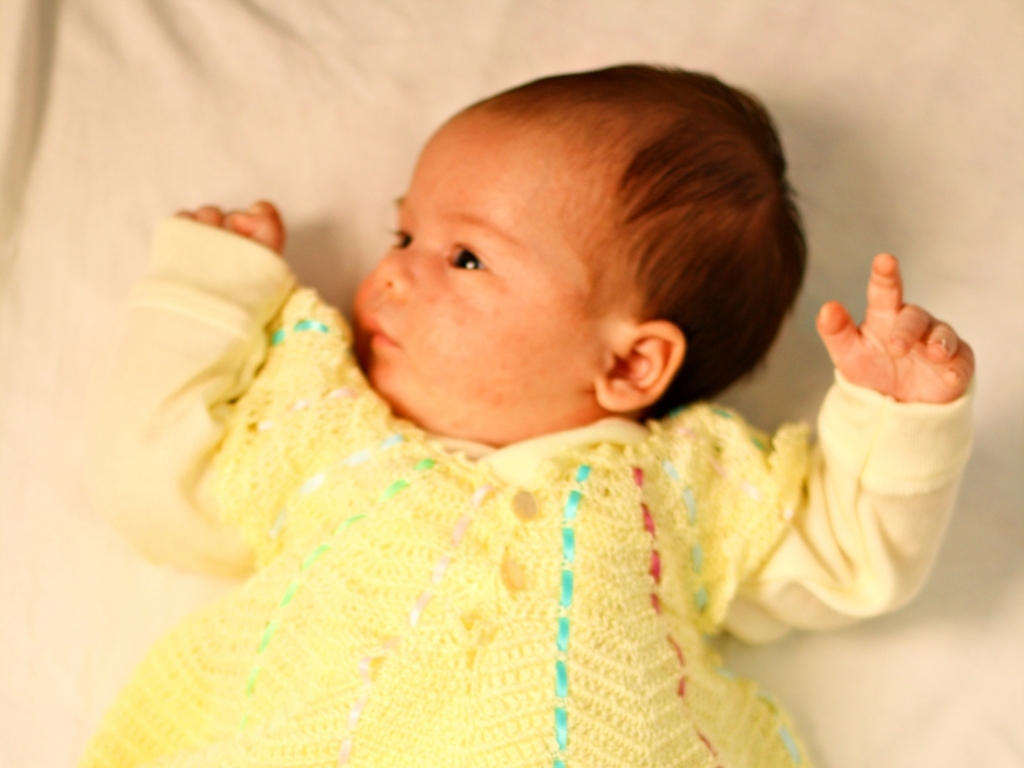Is there any color cast in the image? There appears to be a slight warm color cast in the image, which is common under indoor lighting conditions. This can give the photograph a cozy and pleasant feel, often enhancing the subject's appearance by making skin tones appear softer and warmer. 